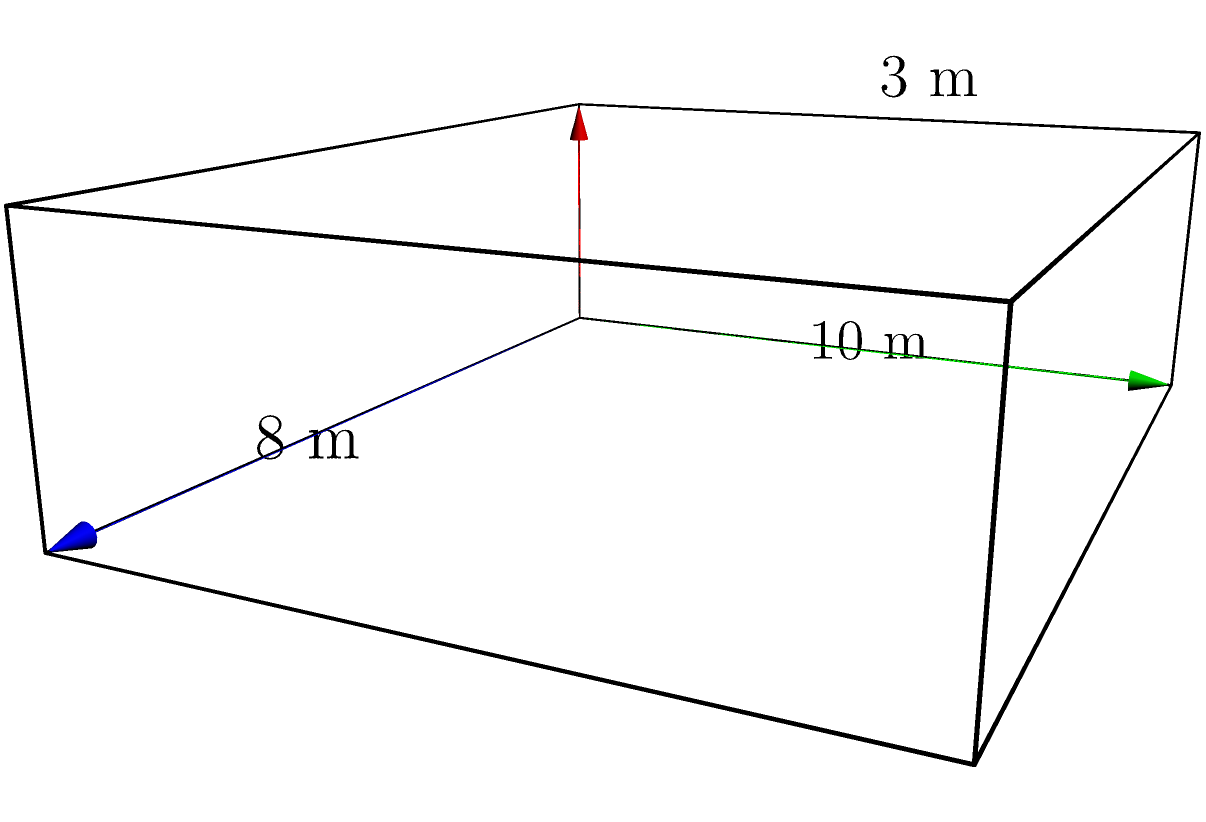As a labor union representative, you're assessing a new office space for workers in a multinational corporation. The office is shaped like a rectangular prism with dimensions 10 m long, 8 m wide, and 3 m high. To ensure adequate worker accommodations, you need to calculate the volume of this space. What is the volume of the office in cubic meters? To calculate the volume of a rectangular prism, we need to multiply its length, width, and height. Let's follow these steps:

1. Identify the dimensions:
   Length (l) = 10 m
   Width (w) = 8 m
   Height (h) = 3 m

2. Apply the formula for the volume of a rectangular prism:
   $V = l \times w \times h$

3. Substitute the values into the formula:
   $V = 10 \text{ m} \times 8 \text{ m} \times 3 \text{ m}$

4. Perform the multiplication:
   $V = 240 \text{ m}^3$

Therefore, the volume of the office space is 240 cubic meters.

This calculation is crucial for ensuring that workers have sufficient space to work comfortably and efficiently. As a labor union representative, you can use this information to advocate for appropriate worker density and to ensure compliance with workplace regulations regarding space per employee.
Answer: 240 m³ 